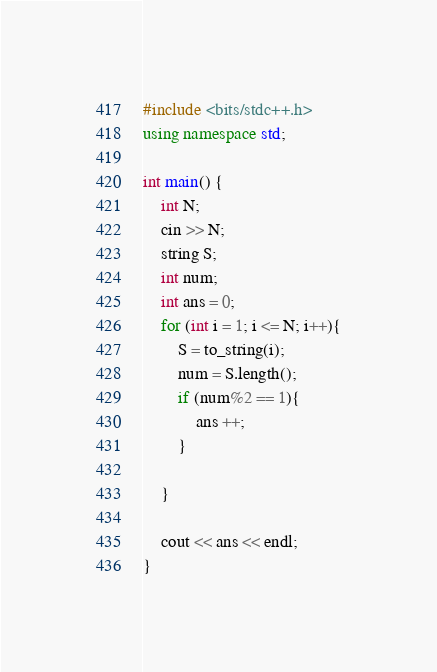<code> <loc_0><loc_0><loc_500><loc_500><_C++_>#include <bits/stdc++.h>
using namespace std;

int main() {
    int N;
    cin >> N;
    string S;
    int num;
    int ans = 0;
    for (int i = 1; i <= N; i++){
        S = to_string(i);
        num = S.length();
        if (num%2 == 1){
            ans ++;
        }
        
    }

    cout << ans << endl;
}
</code> 